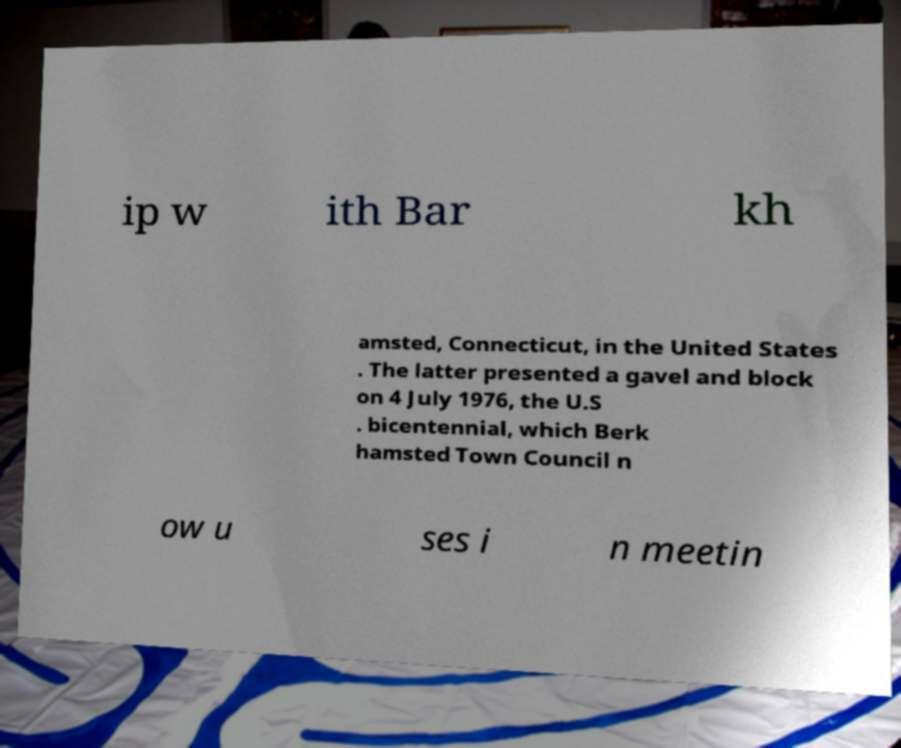There's text embedded in this image that I need extracted. Can you transcribe it verbatim? ip w ith Bar kh amsted, Connecticut, in the United States . The latter presented a gavel and block on 4 July 1976, the U.S . bicentennial, which Berk hamsted Town Council n ow u ses i n meetin 